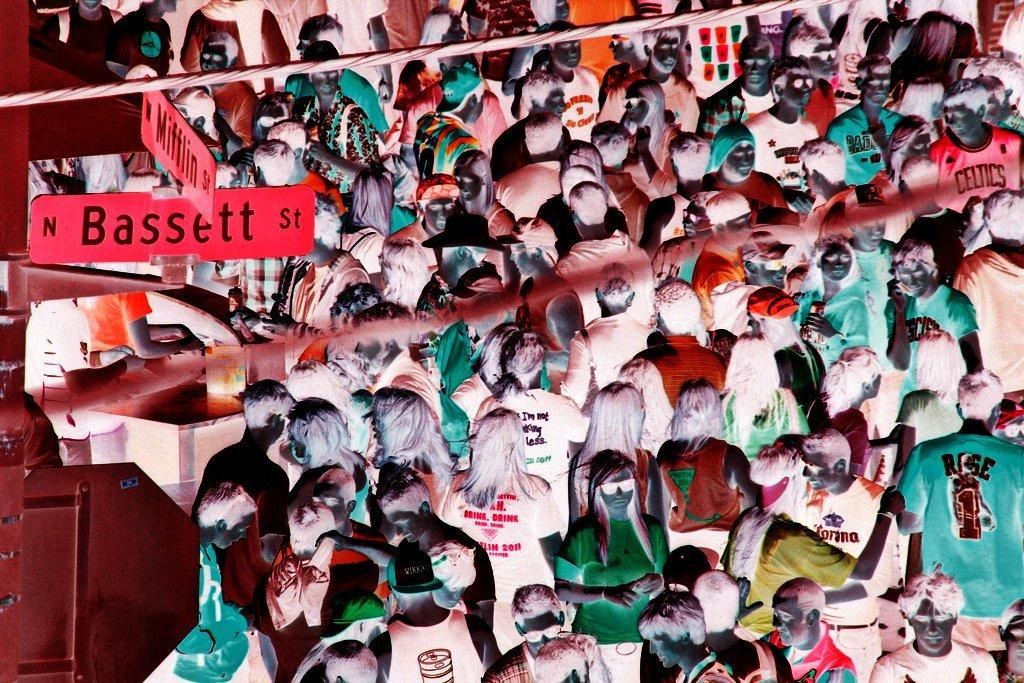<image>
Relay a brief, clear account of the picture shown. A crowd of people wearing all different colors together with the word Bassett st and mifflin st on two red signs. 